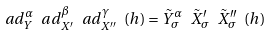Convert formula to latex. <formula><loc_0><loc_0><loc_500><loc_500>a d _ { Y } ^ { \alpha } \ a d _ { X ^ { \prime } } ^ { \beta } \ a d _ { X ^ { \prime \prime } } ^ { \gamma } \ ( h ) = \tilde { Y } _ { \sigma } ^ { \alpha } \ \tilde { X } _ { \sigma } ^ { \prime } \ \tilde { X } _ { \sigma } ^ { \prime \prime } \ ( h )</formula> 